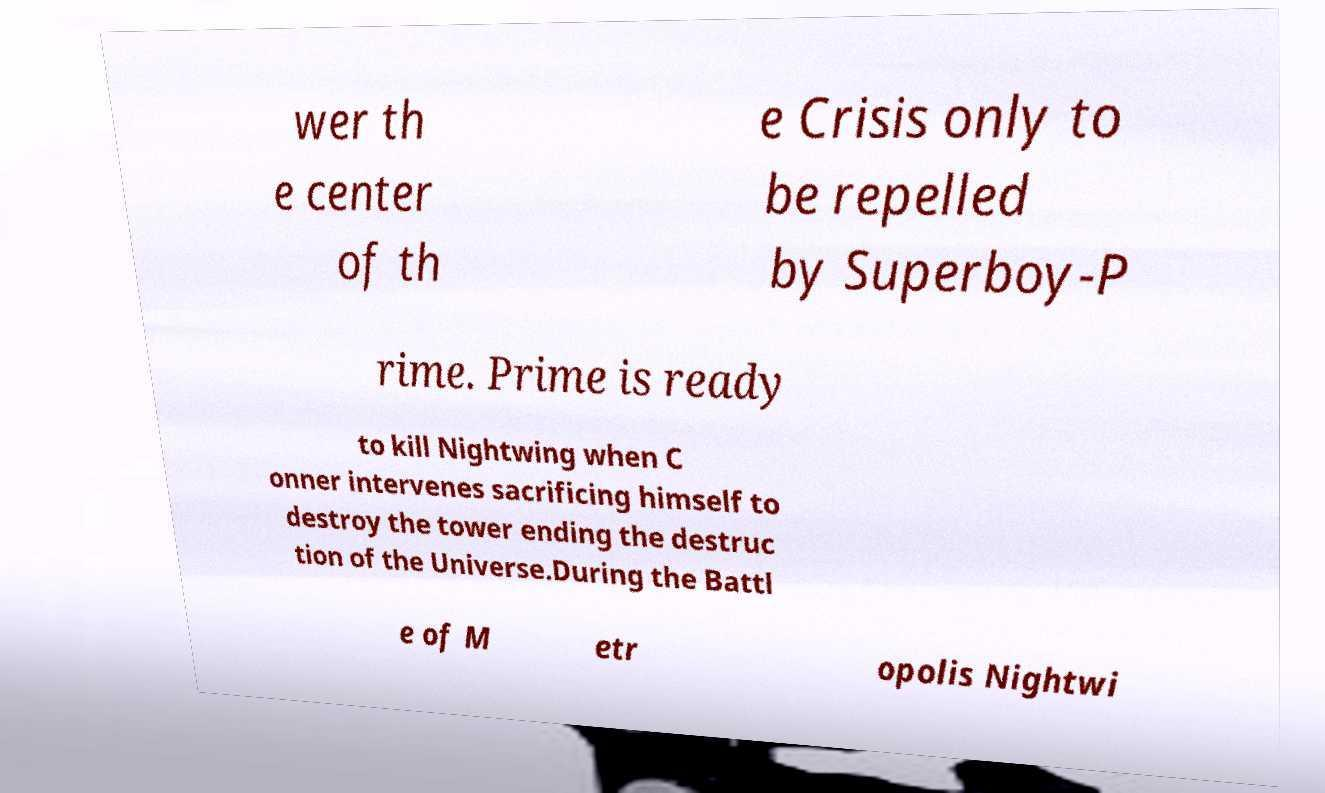There's text embedded in this image that I need extracted. Can you transcribe it verbatim? wer th e center of th e Crisis only to be repelled by Superboy-P rime. Prime is ready to kill Nightwing when C onner intervenes sacrificing himself to destroy the tower ending the destruc tion of the Universe.During the Battl e of M etr opolis Nightwi 